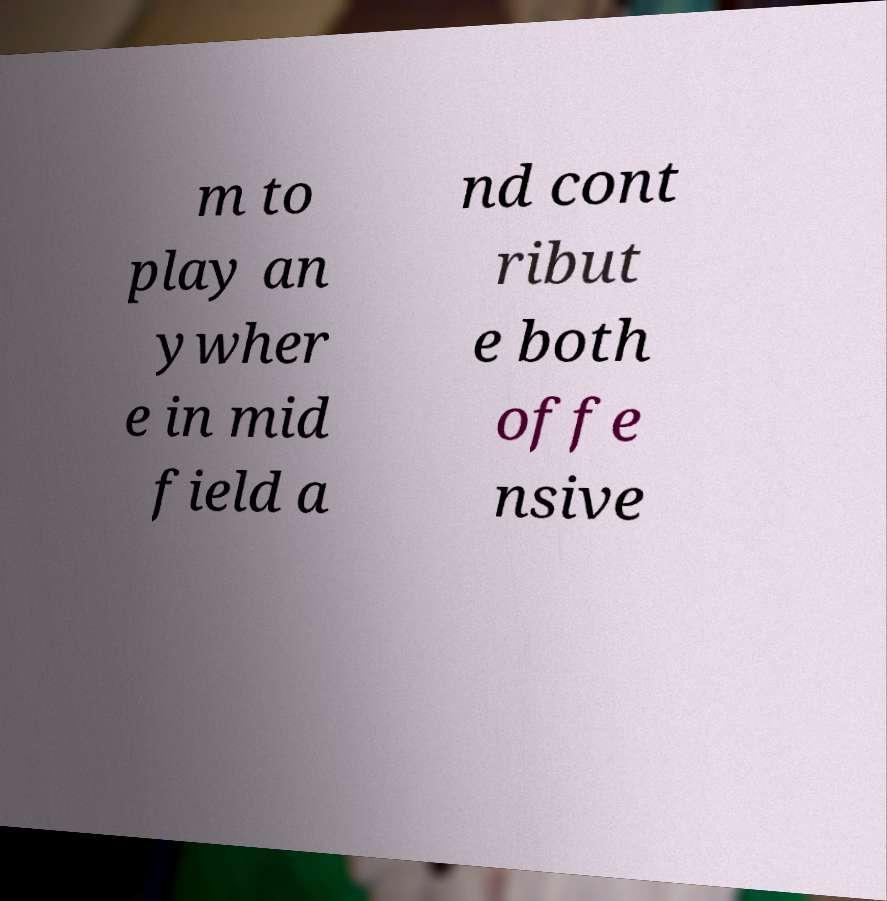What messages or text are displayed in this image? I need them in a readable, typed format. m to play an ywher e in mid field a nd cont ribut e both offe nsive 